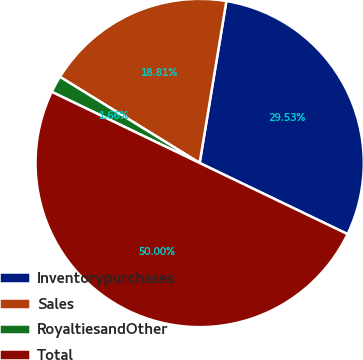Convert chart. <chart><loc_0><loc_0><loc_500><loc_500><pie_chart><fcel>Inventorypurchases<fcel>Sales<fcel>RoyaltiesandOther<fcel>Total<nl><fcel>29.53%<fcel>18.81%<fcel>1.66%<fcel>50.0%<nl></chart> 